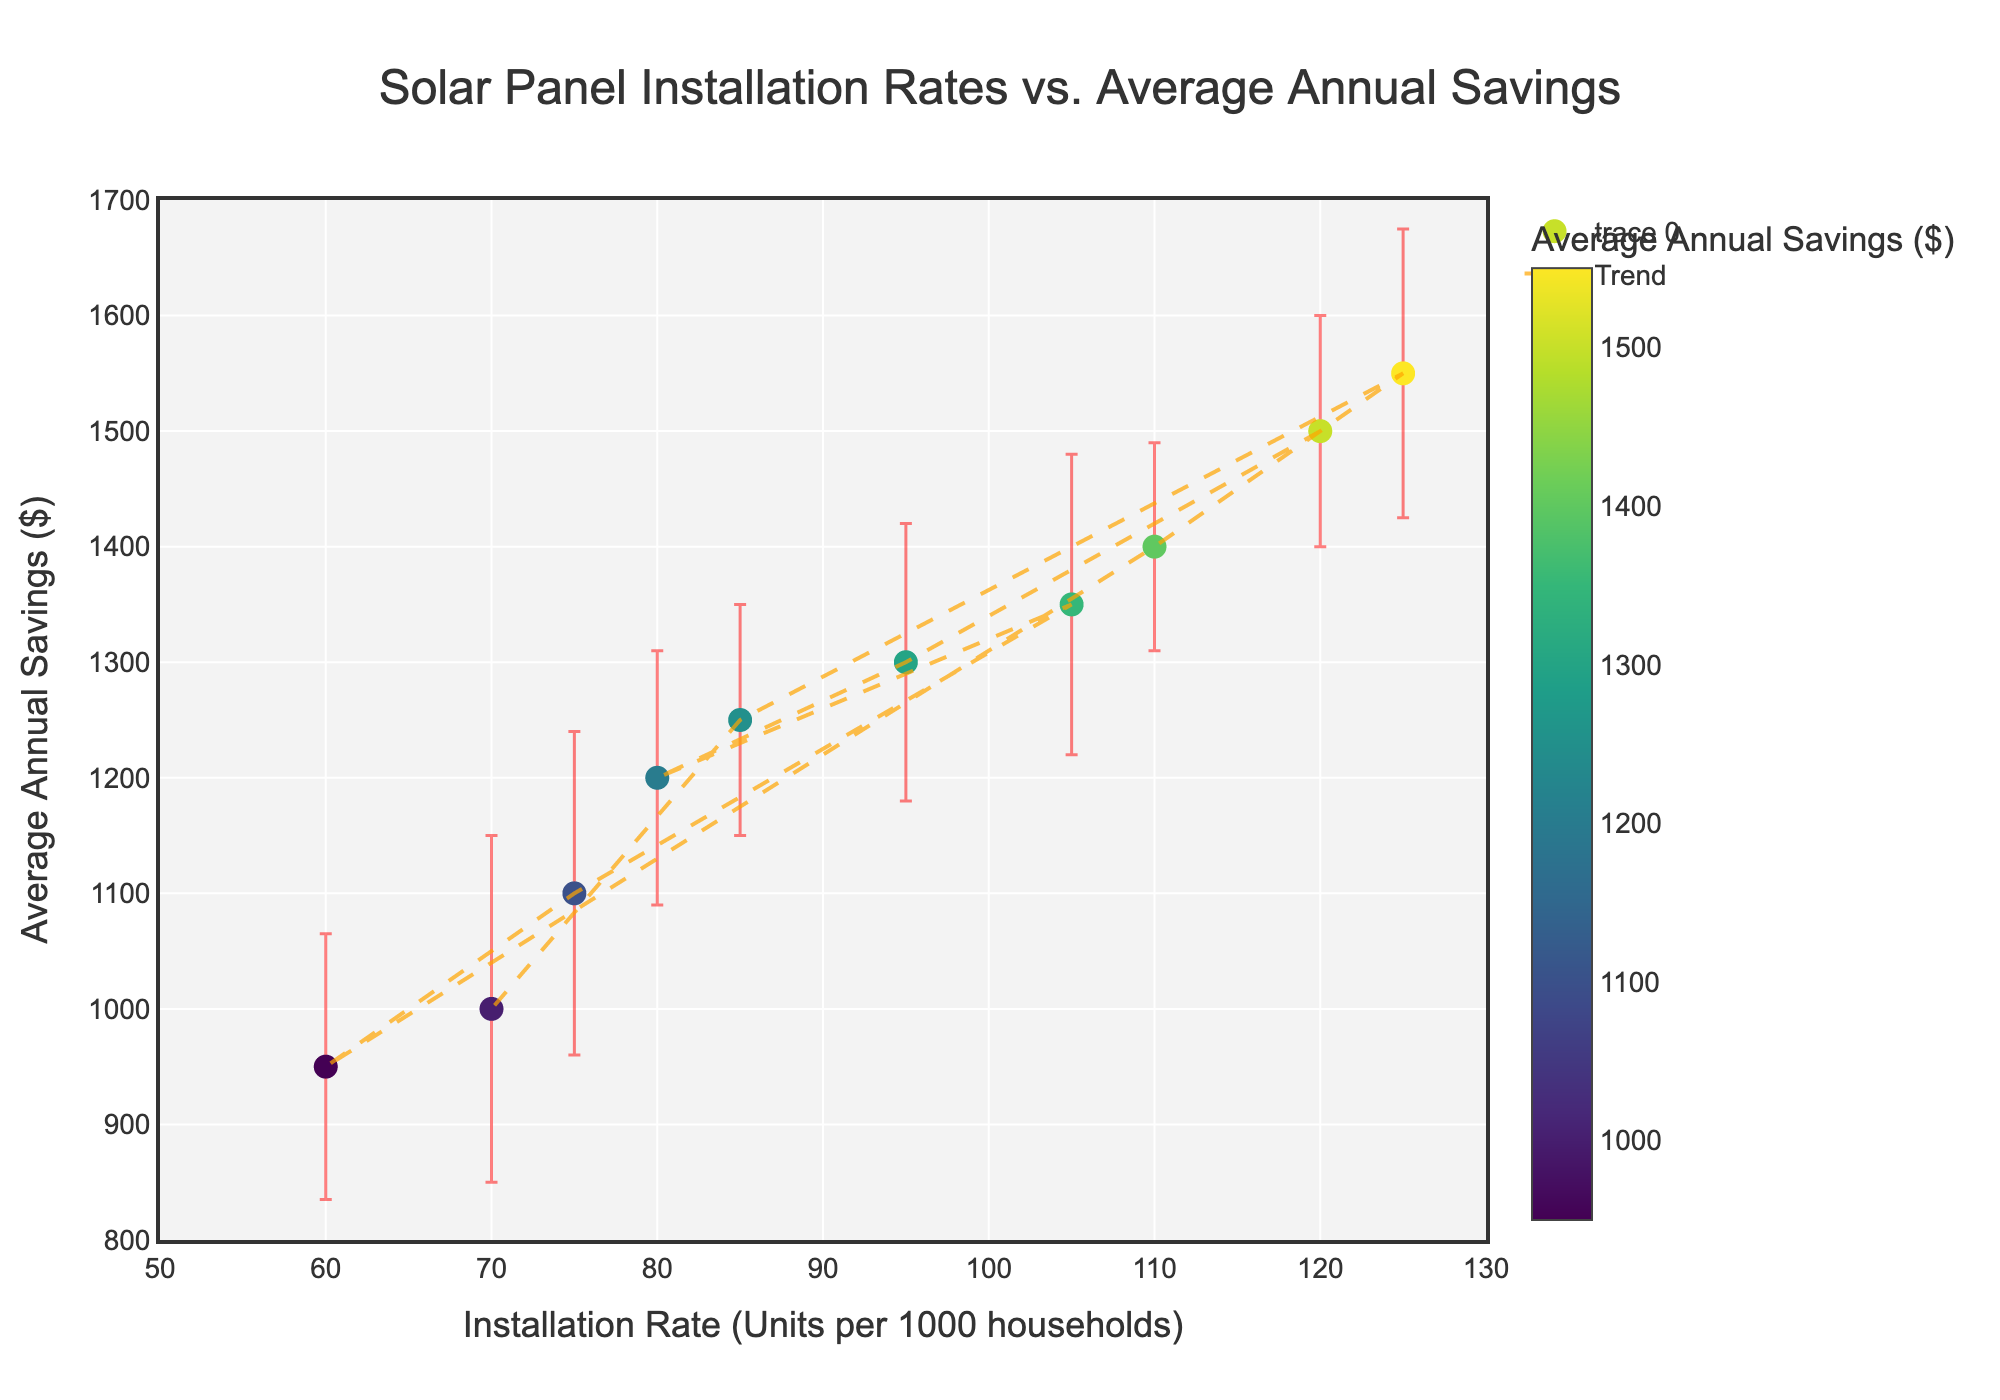How many data points are plotted in the figure? By counting the number of distinct markers on the scatter plot, we can determine the number of data points. Each marker represents one location.
Answer: 10 What is the title of the plot? The title is written at the top of the figure. It is generally centered and in a larger font size.
Answer: Solar Panel Installation Rates vs. Average Annual Savings Which location has the highest installation rate? By identifying the marker with the highest x-axis value, we find the location with the highest installation rate. Checking the hover text of this marker reveals the corresponding location.
Answer: Arizona Which location has the lowest average annual savings? By locating the marker with the lowest y-axis value and checking the hover text, we can identify the location.
Answer: Pennsylvania What are the x and y-axis labels of the plot? The x-axis label can be found below the horizontal axis, while the y-axis label is located to the left of the vertical axis.
Answer: Installation Rate (Units per 1000 households) and Average Annual Savings ($) What is the error margin for Colorado? Checking the data point for Colorado and referring to the error bar associated with this marker reveals the information.
Answer: $90 Which data point has the highest average annual savings, and what is the corresponding installation rate? Identifying the marker at the highest position on the y-axis and reading its x-axis value and hover text provides the required information.
Answer: Arizona, 125 Calculate the average installation rate for California and Texas. Adding the installation rates for California and Texas, then dividing by 2 gives the average: (120 + 95) / 2 = 107.5
Answer: 107.5 Which location's average annual savings has the largest error margin? By finding the marker with the highest length of the error bar in the y-dimension and checking the hover text reveals the location.
Answer: Massachusetts Compare the average annual savings of New York and Florida. Which is higher and by how much? Finding and comparing the y-axis values for New York and Florida, then subtracting New York's savings from Florida’s determines the higher value and the difference: 1350 - 1200 = 150
Answer: Florida by $150 